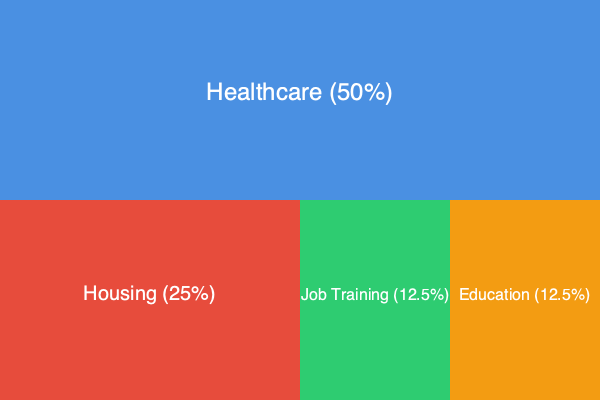Based on the treemap diagram showing the allocation of local government funding for veteran services, which service area receives the largest percentage of funding, and what is the combined percentage allocated to Job Training and Education? To answer this question, we need to analyze the treemap diagram and interpret the information provided:

1. Identifying the largest funding allocation:
   - The treemap is divided into four rectangles, each representing a different service area.
   - The largest rectangle, occupying the entire top half of the diagram, represents Healthcare at 50% of the total funding.

2. Calculating the combined percentage for Job Training and Education:
   - Job Training is represented by a rectangle occupying 12.5% of the total area.
   - Education is also represented by a rectangle occupying 12.5% of the total area.
   - To find the combined percentage, we add these two values:
     $12.5\% + 12.5\% = 25\%$

Therefore, Healthcare receives the largest percentage of funding at 50%, and the combined percentage allocated to Job Training and Education is 25%.
Answer: Healthcare (50%); 25% 